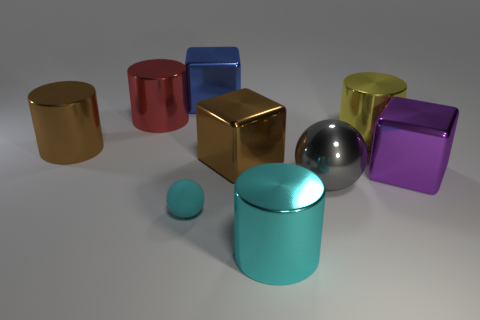What is the size of the metal thing that is the same color as the rubber sphere?
Offer a terse response. Large. There is a cyan thing to the right of the ball that is on the left side of the large cyan metallic cylinder; what number of shiny cylinders are on the left side of it?
Provide a succinct answer. 2. There is a metallic cylinder that is in front of the large gray metal thing; is its color the same as the ball that is on the left side of the big cyan cylinder?
Make the answer very short. Yes. There is a large metallic cylinder that is both in front of the yellow object and on the right side of the brown cube; what color is it?
Keep it short and to the point. Cyan. How many rubber balls are the same size as the purple shiny object?
Your answer should be compact. 0. What shape is the big thing on the right side of the large cylinder right of the gray thing?
Ensure brevity in your answer.  Cube. The brown object that is to the right of the cyan object on the left side of the cylinder in front of the large sphere is what shape?
Offer a very short reply. Cube. What number of matte things have the same shape as the yellow metal object?
Offer a very short reply. 0. How many cylinders are in front of the block that is right of the big cyan metallic object?
Keep it short and to the point. 1. How many shiny things are big gray things or cyan things?
Offer a terse response. 2. 